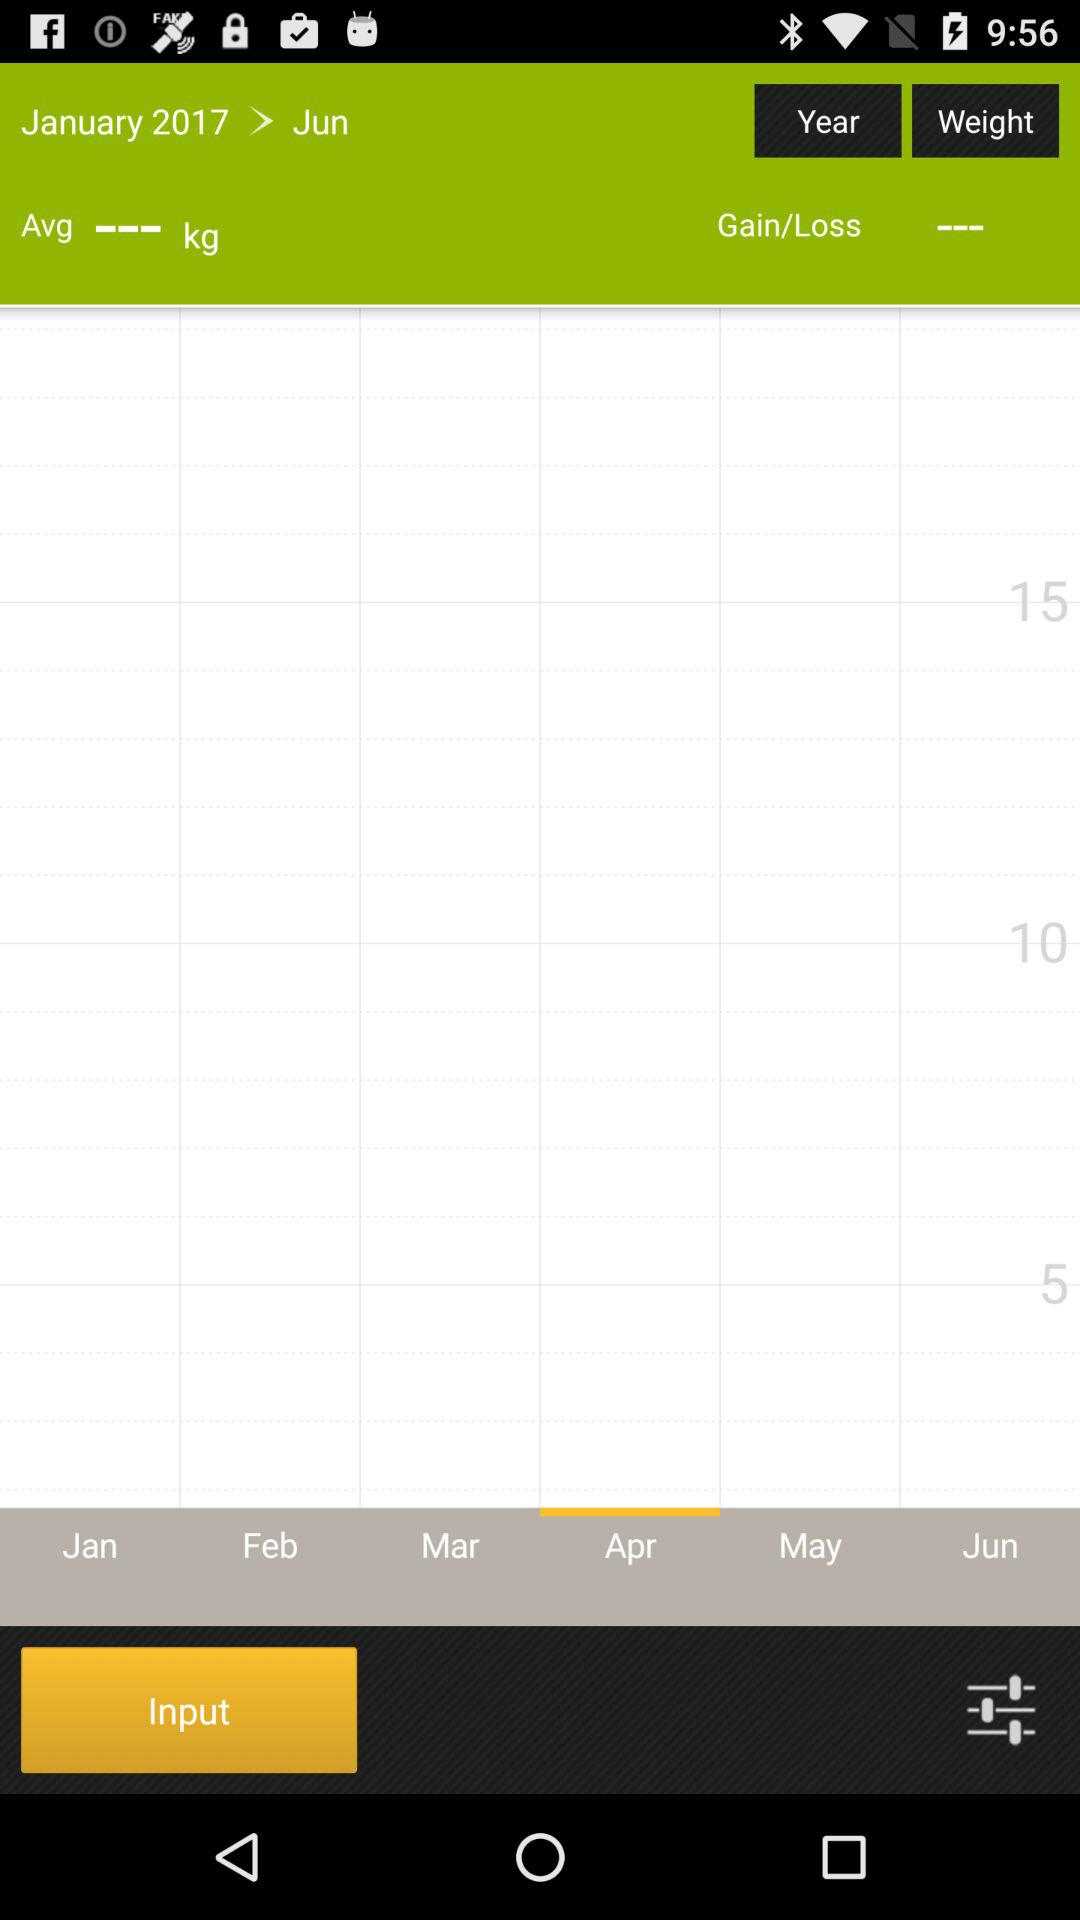Which month is selected? The selected month is April. 